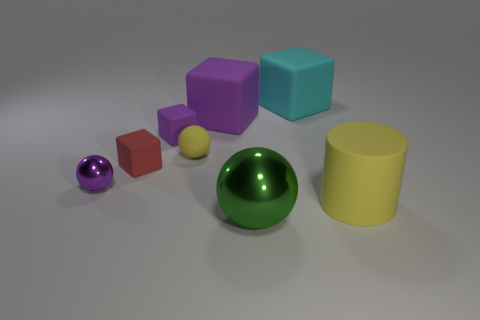Subtract all purple blocks. How many were subtracted if there are1purple blocks left? 1 Subtract all big cyan rubber blocks. How many blocks are left? 3 Subtract all purple cylinders. How many purple cubes are left? 2 Add 1 matte objects. How many objects exist? 9 Subtract all red blocks. How many blocks are left? 3 Subtract 1 cubes. How many cubes are left? 3 Add 2 small yellow spheres. How many small yellow spheres are left? 3 Add 5 tiny red blocks. How many tiny red blocks exist? 6 Subtract 1 green spheres. How many objects are left? 7 Subtract all cylinders. How many objects are left? 7 